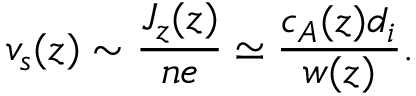<formula> <loc_0><loc_0><loc_500><loc_500>v _ { s } ( z ) \sim \frac { J _ { z } ( z ) } { n e } \simeq \frac { c _ { A } ( z ) d _ { i } } { w ( z ) } .</formula> 